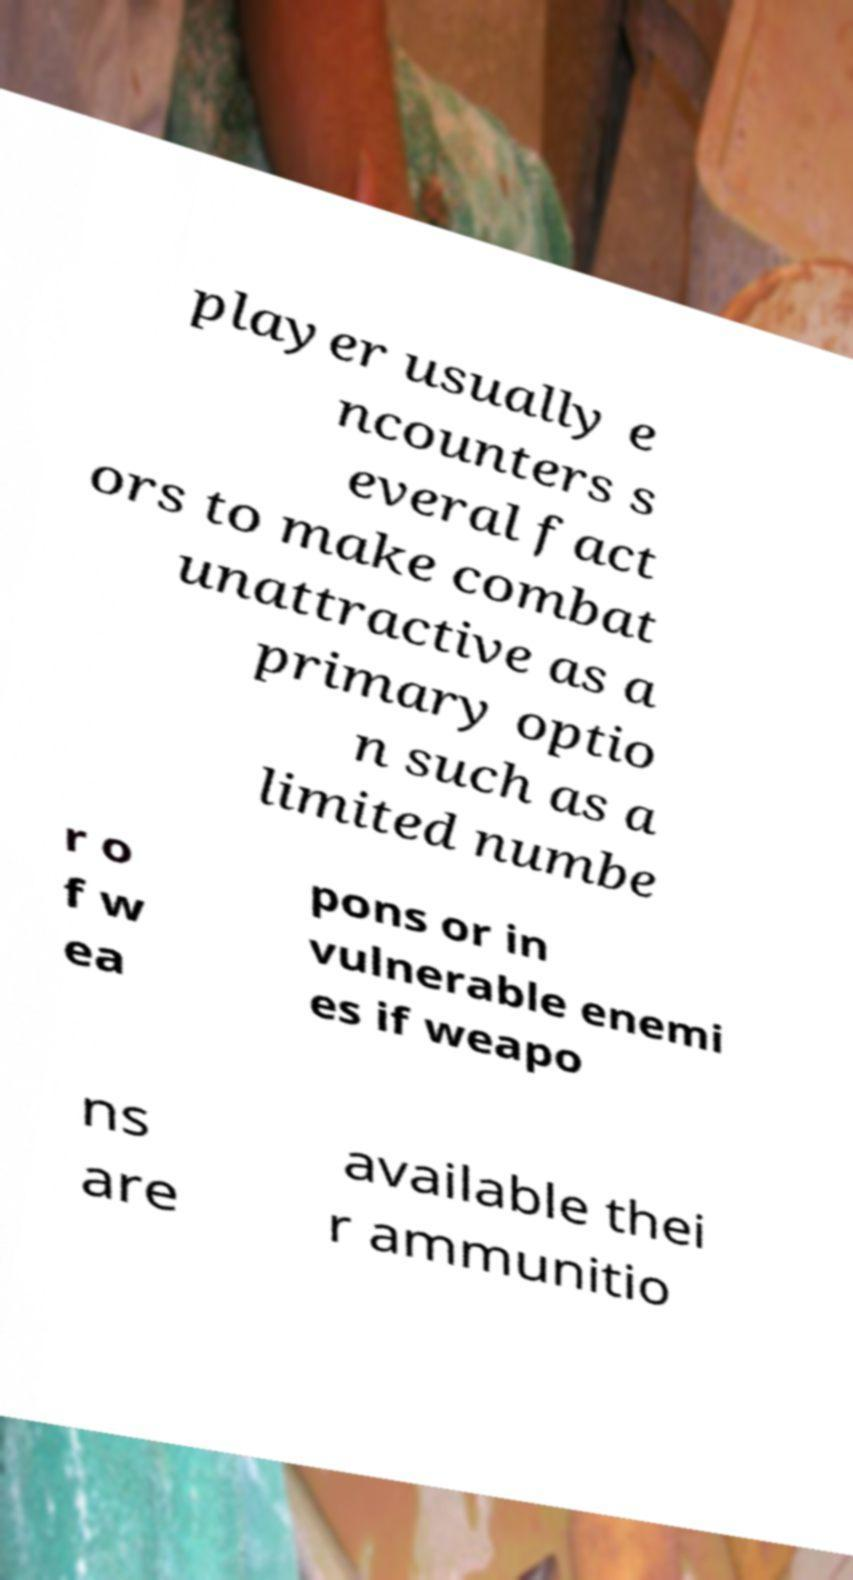There's text embedded in this image that I need extracted. Can you transcribe it verbatim? player usually e ncounters s everal fact ors to make combat unattractive as a primary optio n such as a limited numbe r o f w ea pons or in vulnerable enemi es if weapo ns are available thei r ammunitio 